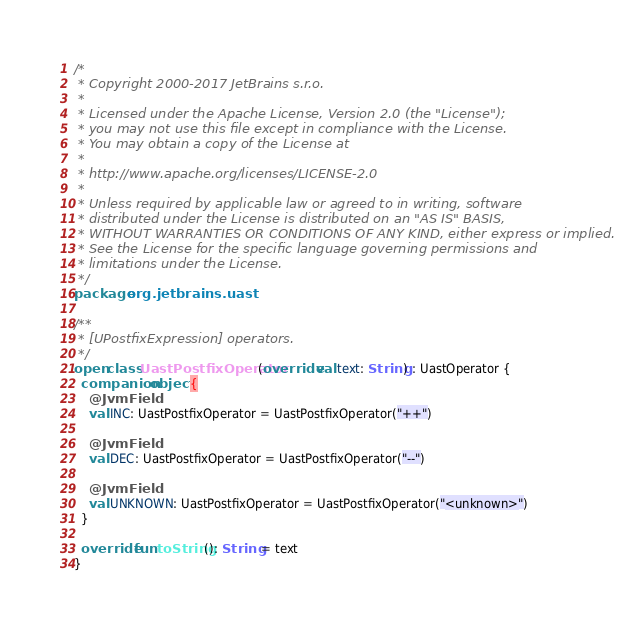<code> <loc_0><loc_0><loc_500><loc_500><_Kotlin_>/*
 * Copyright 2000-2017 JetBrains s.r.o.
 *
 * Licensed under the Apache License, Version 2.0 (the "License");
 * you may not use this file except in compliance with the License.
 * You may obtain a copy of the License at
 *
 * http://www.apache.org/licenses/LICENSE-2.0
 *
 * Unless required by applicable law or agreed to in writing, software
 * distributed under the License is distributed on an "AS IS" BASIS,
 * WITHOUT WARRANTIES OR CONDITIONS OF ANY KIND, either express or implied.
 * See the License for the specific language governing permissions and
 * limitations under the License.
 */
package org.jetbrains.uast

/**
 * [UPostfixExpression] operators.
 */
open class UastPostfixOperator(override val text: String) : UastOperator {
  companion object {
    @JvmField
    val INC: UastPostfixOperator = UastPostfixOperator("++")

    @JvmField
    val DEC: UastPostfixOperator = UastPostfixOperator("--")

    @JvmField
    val UNKNOWN: UastPostfixOperator = UastPostfixOperator("<unknown>")
  }

  override fun toString(): String = text
}
</code> 